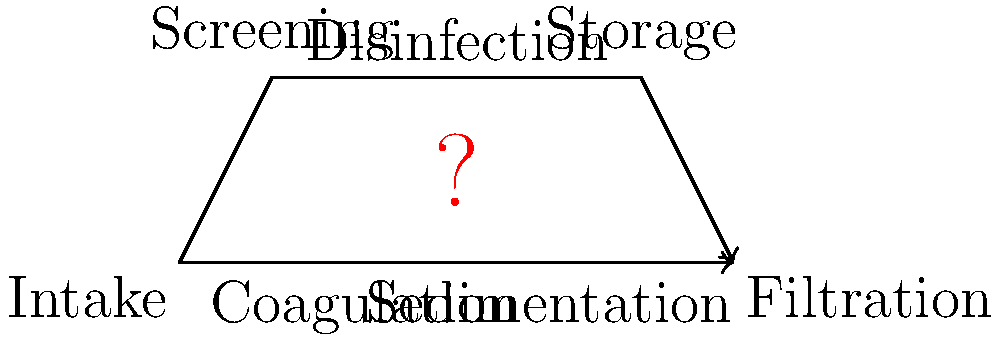In a water treatment process diagram shown in an environmental documentary, which step is typically performed between coagulation and sedimentation to enhance the removal of suspended particles? To answer this question, let's break down the water treatment process step-by-step:

1. The diagram shows two main process flows: a linear flow at the bottom and a branched flow above.

2. The linear flow represents the primary treatment steps:
   a) Intake
   b) Coagulation
   c) Sedimentation
   d) Filtration

3. The question mark is placed between coagulation and sedimentation, indicating a missing step.

4. In water treatment, after coagulation (where chemicals are added to destabilize particles), there's typically a mixing step to enhance particle collision and aggregation.

5. This missing step is called flocculation. During flocculation, gentle mixing allows the destabilized particles to collide and form larger, more easily settleable flocs.

6. Flocculation is crucial because it bridges the gap between coagulation (particle destabilization) and sedimentation (settling of particles).

7. In environmental documentaries, this step is often highlighted as it visually demonstrates how small particles clump together, making the water treatment process more efficient.

Therefore, the step typically performed between coagulation and sedimentation in a water treatment process is flocculation.
Answer: Flocculation 